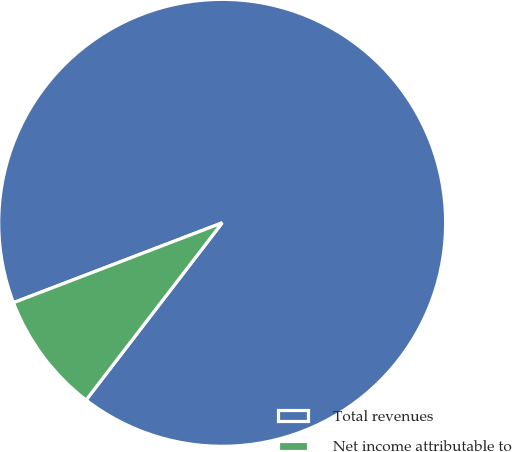Convert chart to OTSL. <chart><loc_0><loc_0><loc_500><loc_500><pie_chart><fcel>Total revenues<fcel>Net income attributable to<nl><fcel>91.24%<fcel>8.76%<nl></chart> 